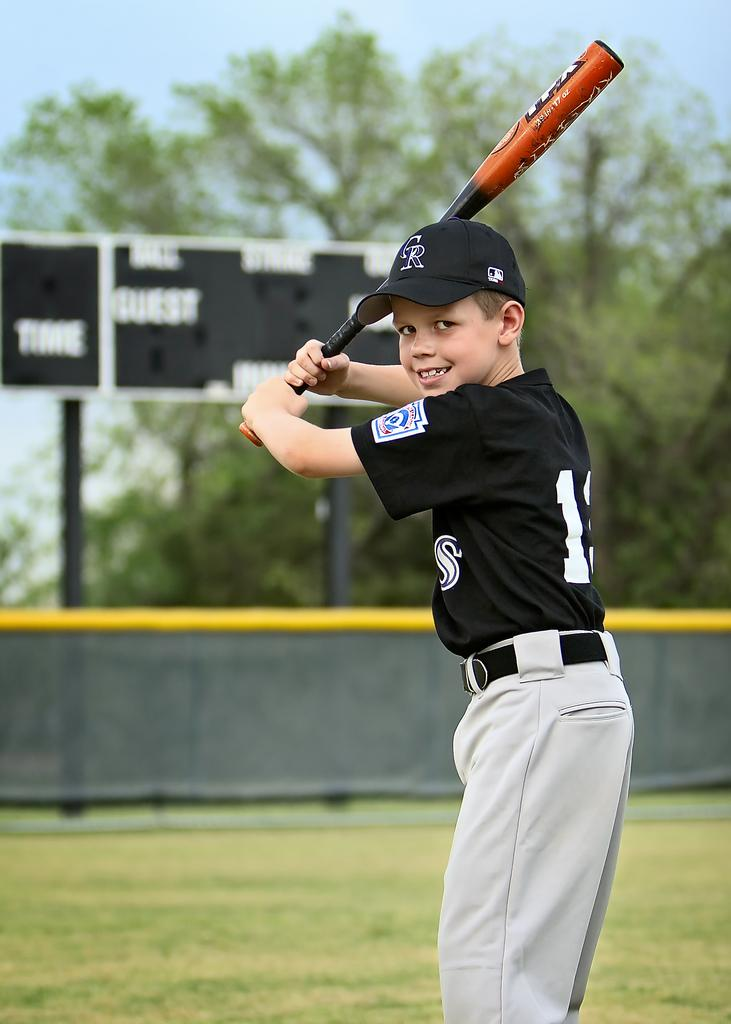Provide a one-sentence caption for the provided image. A Colorado Rockies fan is standing with a bat ready to take a swing. 